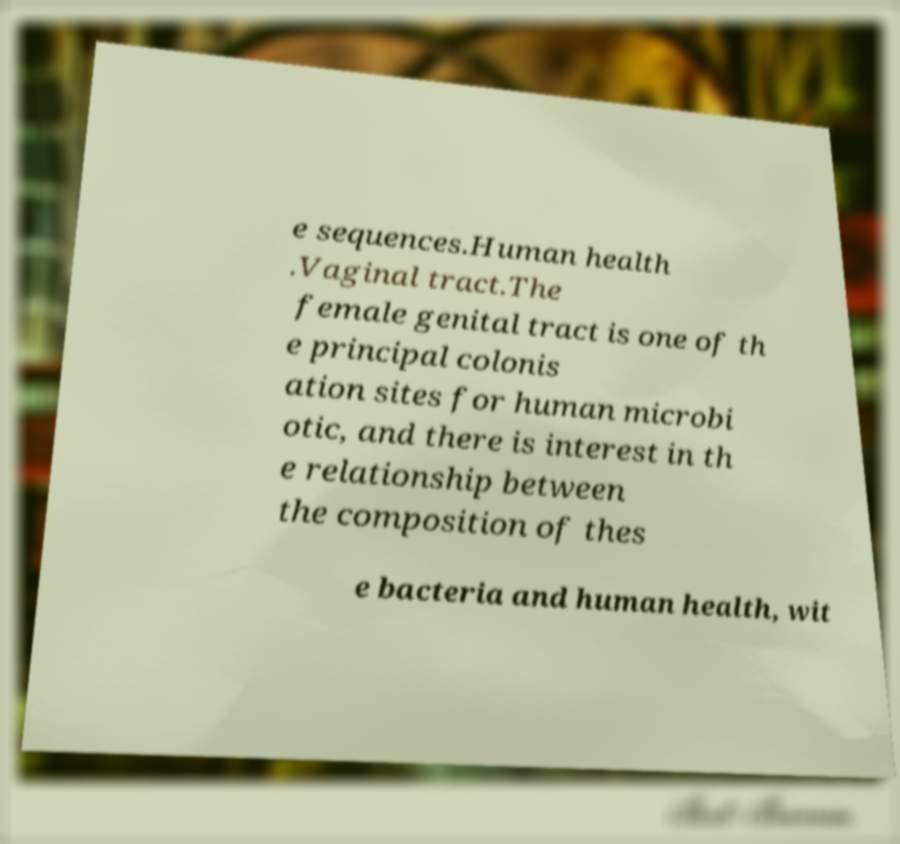Can you accurately transcribe the text from the provided image for me? e sequences.Human health .Vaginal tract.The female genital tract is one of th e principal colonis ation sites for human microbi otic, and there is interest in th e relationship between the composition of thes e bacteria and human health, wit 